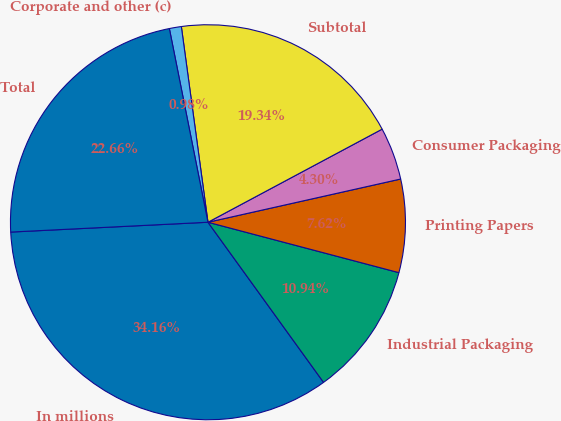Convert chart to OTSL. <chart><loc_0><loc_0><loc_500><loc_500><pie_chart><fcel>In millions<fcel>Industrial Packaging<fcel>Printing Papers<fcel>Consumer Packaging<fcel>Subtotal<fcel>Corporate and other (c)<fcel>Total<nl><fcel>34.16%<fcel>10.94%<fcel>7.62%<fcel>4.3%<fcel>19.34%<fcel>0.98%<fcel>22.66%<nl></chart> 